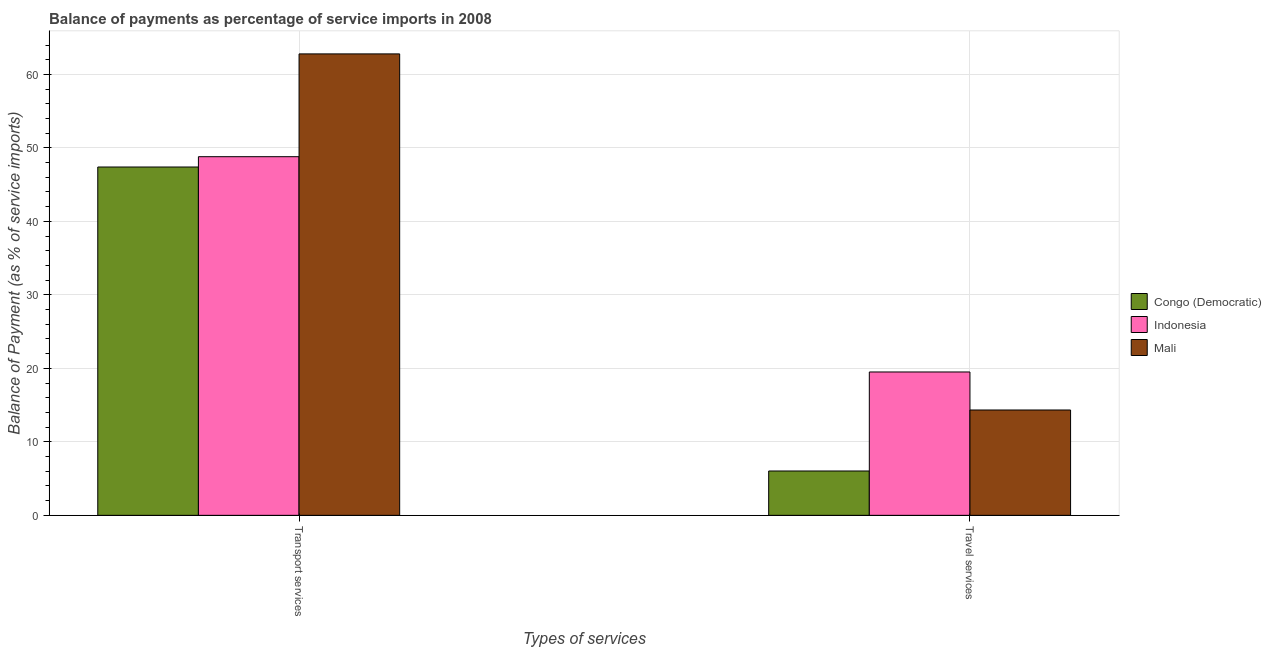How many bars are there on the 1st tick from the left?
Make the answer very short. 3. How many bars are there on the 2nd tick from the right?
Provide a succinct answer. 3. What is the label of the 1st group of bars from the left?
Ensure brevity in your answer.  Transport services. What is the balance of payments of travel services in Indonesia?
Your answer should be very brief. 19.51. Across all countries, what is the maximum balance of payments of transport services?
Your response must be concise. 62.79. Across all countries, what is the minimum balance of payments of transport services?
Provide a short and direct response. 47.4. In which country was the balance of payments of transport services maximum?
Your answer should be compact. Mali. In which country was the balance of payments of travel services minimum?
Ensure brevity in your answer.  Congo (Democratic). What is the total balance of payments of transport services in the graph?
Make the answer very short. 159. What is the difference between the balance of payments of transport services in Indonesia and that in Mali?
Make the answer very short. -13.99. What is the difference between the balance of payments of travel services in Mali and the balance of payments of transport services in Indonesia?
Keep it short and to the point. -34.47. What is the average balance of payments of travel services per country?
Your answer should be compact. 13.29. What is the difference between the balance of payments of travel services and balance of payments of transport services in Indonesia?
Your response must be concise. -29.3. In how many countries, is the balance of payments of travel services greater than 54 %?
Ensure brevity in your answer.  0. What is the ratio of the balance of payments of transport services in Congo (Democratic) to that in Mali?
Give a very brief answer. 0.75. Is the balance of payments of transport services in Indonesia less than that in Mali?
Provide a succinct answer. Yes. What does the 3rd bar from the left in Transport services represents?
Keep it short and to the point. Mali. What does the 1st bar from the right in Travel services represents?
Offer a very short reply. Mali. How many bars are there?
Give a very brief answer. 6. What is the difference between two consecutive major ticks on the Y-axis?
Provide a succinct answer. 10. Are the values on the major ticks of Y-axis written in scientific E-notation?
Offer a terse response. No. How are the legend labels stacked?
Your answer should be very brief. Vertical. What is the title of the graph?
Offer a very short reply. Balance of payments as percentage of service imports in 2008. What is the label or title of the X-axis?
Your response must be concise. Types of services. What is the label or title of the Y-axis?
Your answer should be compact. Balance of Payment (as % of service imports). What is the Balance of Payment (as % of service imports) in Congo (Democratic) in Transport services?
Offer a very short reply. 47.4. What is the Balance of Payment (as % of service imports) in Indonesia in Transport services?
Ensure brevity in your answer.  48.8. What is the Balance of Payment (as % of service imports) in Mali in Transport services?
Your response must be concise. 62.79. What is the Balance of Payment (as % of service imports) of Congo (Democratic) in Travel services?
Your response must be concise. 6.03. What is the Balance of Payment (as % of service imports) in Indonesia in Travel services?
Give a very brief answer. 19.51. What is the Balance of Payment (as % of service imports) of Mali in Travel services?
Provide a succinct answer. 14.34. Across all Types of services, what is the maximum Balance of Payment (as % of service imports) in Congo (Democratic)?
Make the answer very short. 47.4. Across all Types of services, what is the maximum Balance of Payment (as % of service imports) of Indonesia?
Your answer should be very brief. 48.8. Across all Types of services, what is the maximum Balance of Payment (as % of service imports) of Mali?
Make the answer very short. 62.79. Across all Types of services, what is the minimum Balance of Payment (as % of service imports) in Congo (Democratic)?
Make the answer very short. 6.03. Across all Types of services, what is the minimum Balance of Payment (as % of service imports) in Indonesia?
Ensure brevity in your answer.  19.51. Across all Types of services, what is the minimum Balance of Payment (as % of service imports) of Mali?
Give a very brief answer. 14.34. What is the total Balance of Payment (as % of service imports) of Congo (Democratic) in the graph?
Provide a short and direct response. 53.43. What is the total Balance of Payment (as % of service imports) of Indonesia in the graph?
Your answer should be compact. 68.31. What is the total Balance of Payment (as % of service imports) of Mali in the graph?
Give a very brief answer. 77.13. What is the difference between the Balance of Payment (as % of service imports) of Congo (Democratic) in Transport services and that in Travel services?
Your response must be concise. 41.37. What is the difference between the Balance of Payment (as % of service imports) of Indonesia in Transport services and that in Travel services?
Your answer should be very brief. 29.3. What is the difference between the Balance of Payment (as % of service imports) of Mali in Transport services and that in Travel services?
Keep it short and to the point. 48.46. What is the difference between the Balance of Payment (as % of service imports) of Congo (Democratic) in Transport services and the Balance of Payment (as % of service imports) of Indonesia in Travel services?
Keep it short and to the point. 27.89. What is the difference between the Balance of Payment (as % of service imports) of Congo (Democratic) in Transport services and the Balance of Payment (as % of service imports) of Mali in Travel services?
Ensure brevity in your answer.  33.06. What is the difference between the Balance of Payment (as % of service imports) of Indonesia in Transport services and the Balance of Payment (as % of service imports) of Mali in Travel services?
Your response must be concise. 34.47. What is the average Balance of Payment (as % of service imports) of Congo (Democratic) per Types of services?
Keep it short and to the point. 26.72. What is the average Balance of Payment (as % of service imports) of Indonesia per Types of services?
Ensure brevity in your answer.  34.16. What is the average Balance of Payment (as % of service imports) in Mali per Types of services?
Ensure brevity in your answer.  38.56. What is the difference between the Balance of Payment (as % of service imports) of Congo (Democratic) and Balance of Payment (as % of service imports) of Indonesia in Transport services?
Provide a succinct answer. -1.4. What is the difference between the Balance of Payment (as % of service imports) in Congo (Democratic) and Balance of Payment (as % of service imports) in Mali in Transport services?
Keep it short and to the point. -15.39. What is the difference between the Balance of Payment (as % of service imports) of Indonesia and Balance of Payment (as % of service imports) of Mali in Transport services?
Your response must be concise. -13.99. What is the difference between the Balance of Payment (as % of service imports) in Congo (Democratic) and Balance of Payment (as % of service imports) in Indonesia in Travel services?
Offer a very short reply. -13.47. What is the difference between the Balance of Payment (as % of service imports) of Congo (Democratic) and Balance of Payment (as % of service imports) of Mali in Travel services?
Your answer should be compact. -8.3. What is the difference between the Balance of Payment (as % of service imports) of Indonesia and Balance of Payment (as % of service imports) of Mali in Travel services?
Your answer should be compact. 5.17. What is the ratio of the Balance of Payment (as % of service imports) of Congo (Democratic) in Transport services to that in Travel services?
Keep it short and to the point. 7.85. What is the ratio of the Balance of Payment (as % of service imports) in Indonesia in Transport services to that in Travel services?
Your answer should be very brief. 2.5. What is the ratio of the Balance of Payment (as % of service imports) of Mali in Transport services to that in Travel services?
Offer a very short reply. 4.38. What is the difference between the highest and the second highest Balance of Payment (as % of service imports) of Congo (Democratic)?
Your answer should be compact. 41.37. What is the difference between the highest and the second highest Balance of Payment (as % of service imports) of Indonesia?
Offer a very short reply. 29.3. What is the difference between the highest and the second highest Balance of Payment (as % of service imports) in Mali?
Ensure brevity in your answer.  48.46. What is the difference between the highest and the lowest Balance of Payment (as % of service imports) of Congo (Democratic)?
Provide a short and direct response. 41.37. What is the difference between the highest and the lowest Balance of Payment (as % of service imports) of Indonesia?
Your answer should be very brief. 29.3. What is the difference between the highest and the lowest Balance of Payment (as % of service imports) of Mali?
Keep it short and to the point. 48.46. 